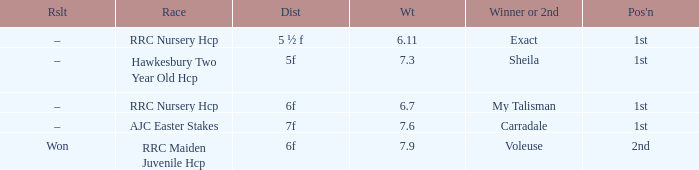What was the name of the winner or 2nd when the result was –, and weight was 6.7? My Talisman. 